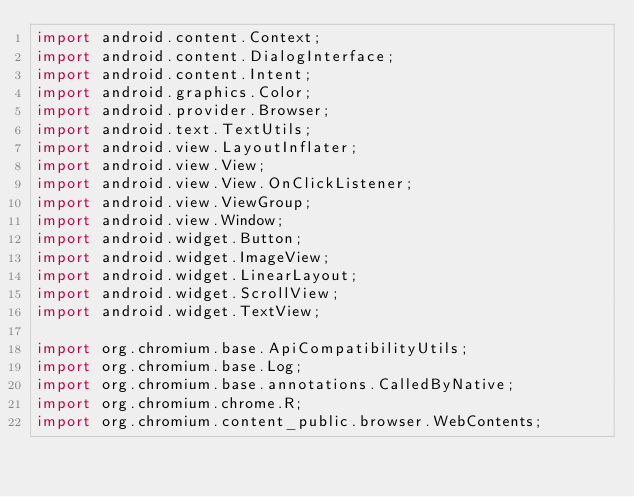<code> <loc_0><loc_0><loc_500><loc_500><_Java_>import android.content.Context;
import android.content.DialogInterface;
import android.content.Intent;
import android.graphics.Color;
import android.provider.Browser;
import android.text.TextUtils;
import android.view.LayoutInflater;
import android.view.View;
import android.view.View.OnClickListener;
import android.view.ViewGroup;
import android.view.Window;
import android.widget.Button;
import android.widget.ImageView;
import android.widget.LinearLayout;
import android.widget.ScrollView;
import android.widget.TextView;

import org.chromium.base.ApiCompatibilityUtils;
import org.chromium.base.Log;
import org.chromium.base.annotations.CalledByNative;
import org.chromium.chrome.R;
import org.chromium.content_public.browser.WebContents;</code> 